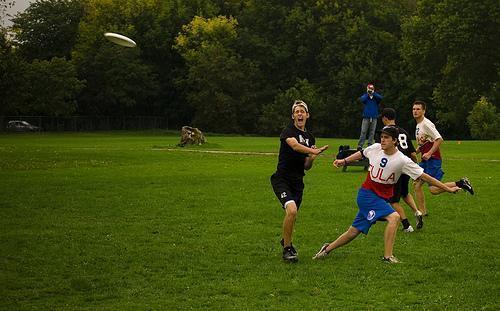How many people are wearing blue shorts?
Give a very brief answer. 2. How many people are there?
Give a very brief answer. 5. How many people can you see?
Give a very brief answer. 3. How many train cars are orange?
Give a very brief answer. 0. 